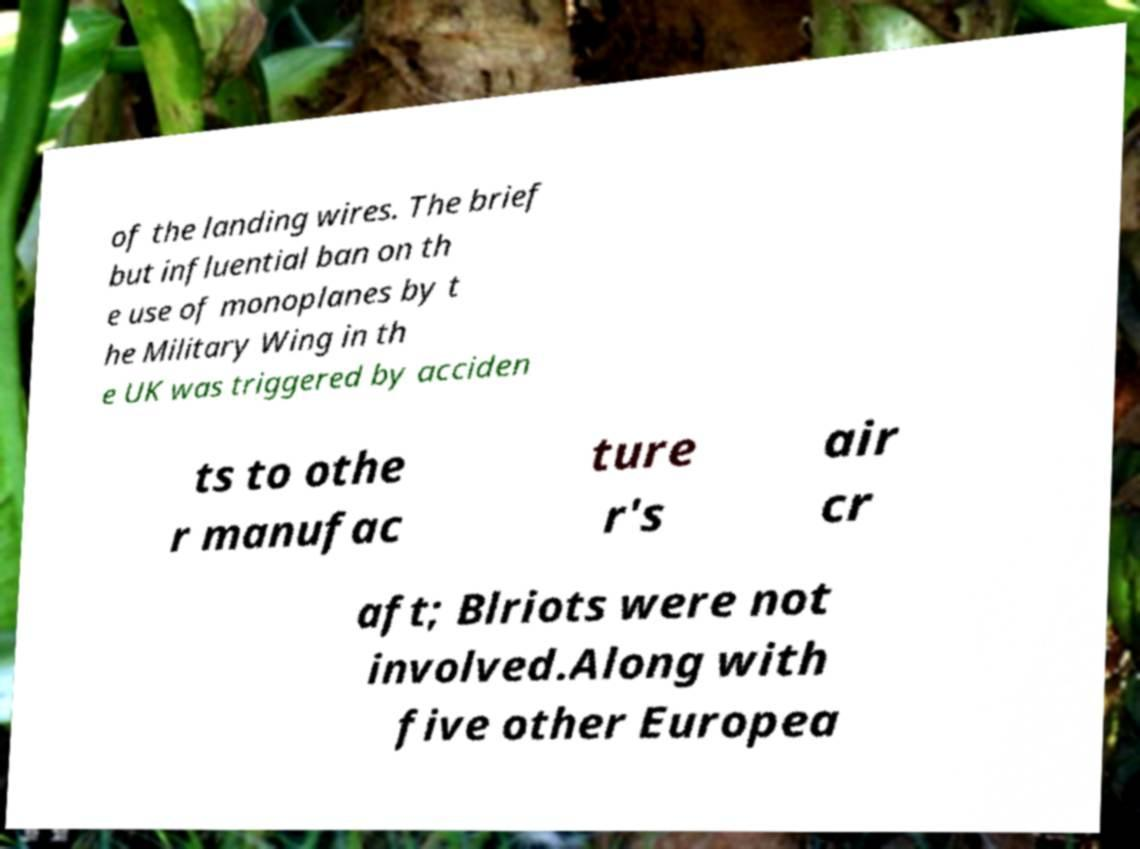Please read and relay the text visible in this image. What does it say? of the landing wires. The brief but influential ban on th e use of monoplanes by t he Military Wing in th e UK was triggered by acciden ts to othe r manufac ture r's air cr aft; Blriots were not involved.Along with five other Europea 